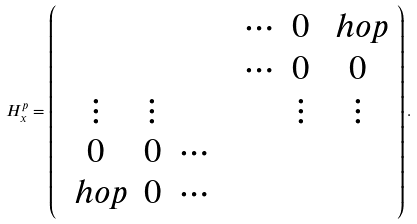<formula> <loc_0><loc_0><loc_500><loc_500>H _ { x } ^ { p } = \left ( \begin{array} { c c c c c c c } & & & & \cdots & 0 & \ h o p \\ & & & & \cdots & 0 & 0 \\ \vdots & \vdots & & & & \vdots & \vdots \\ 0 & 0 & \cdots & & & & \\ \ h o p & 0 & \cdots & & & & \end{array} \right ) .</formula> 